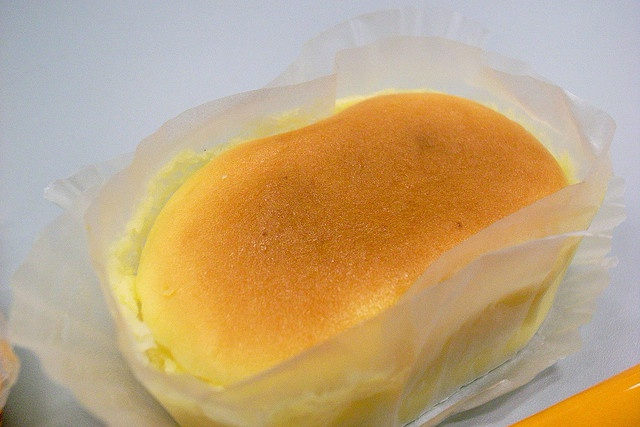Describe the objects in this image and their specific colors. I can see a cake in darkgray, tan, and orange tones in this image. 